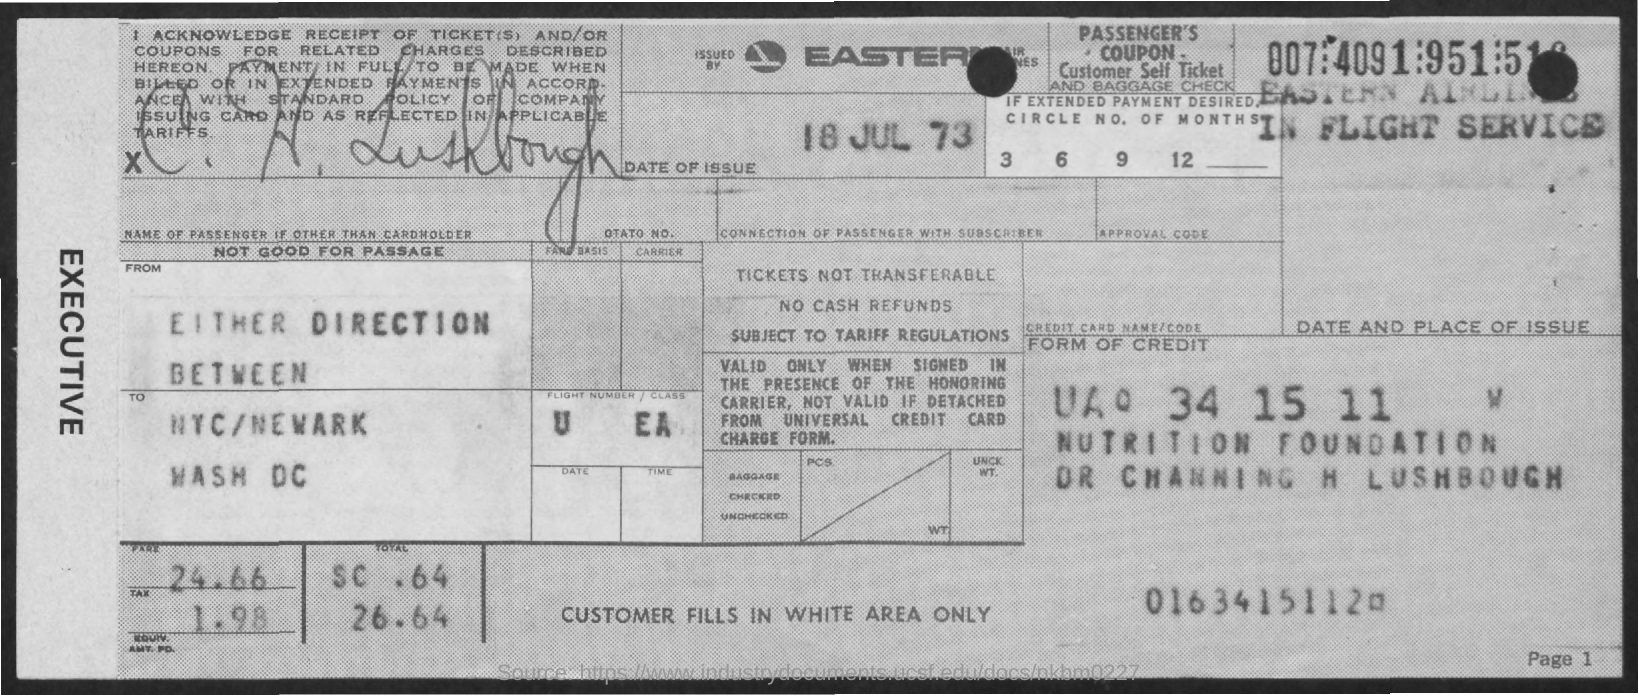What is the date of Issue?
Provide a succinct answer. 18 JUL 73. What is the Fare?
Provide a succinct answer. 24.66. What is the Tax?
Ensure brevity in your answer.  1.98. 